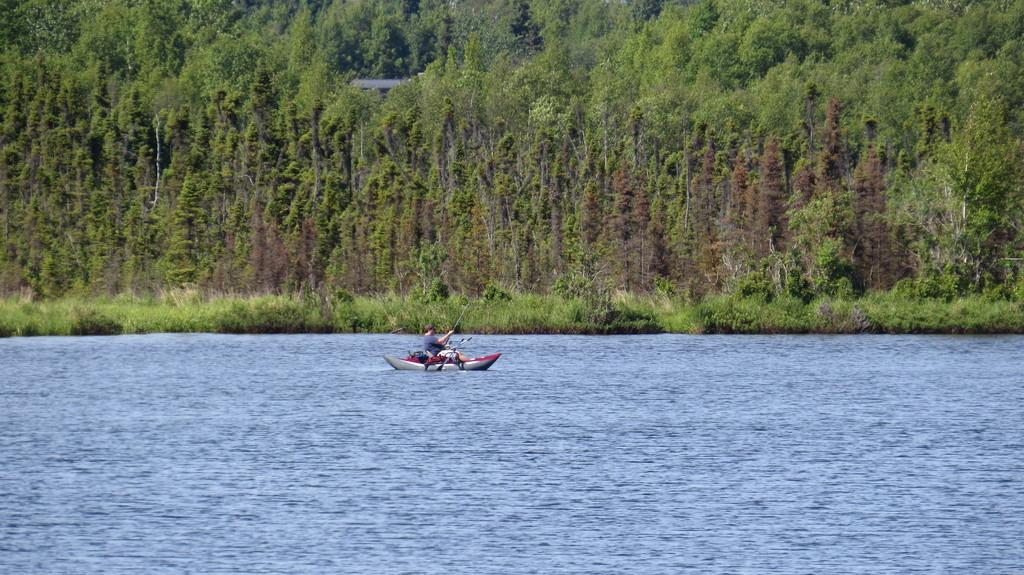Who is present in the image? There is a man in the image. What is the man doing in the image? The man is sitting in a boat. Where is the boat located? The boat is on the water. What is the man holding in the image? The man is holding a fishing rod. What can be seen in the background of the image? There are trees, plants, and an unspecified object in the background of the image. What type of basin can be seen in the image? There is no basin present in the image. What shape is the marble in the image? There is no marble present in the image. 